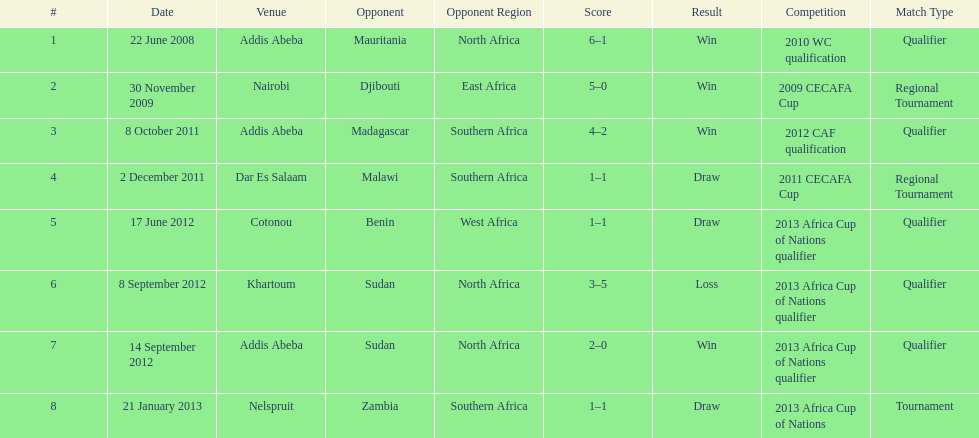How long in years down this table cover? 5. 